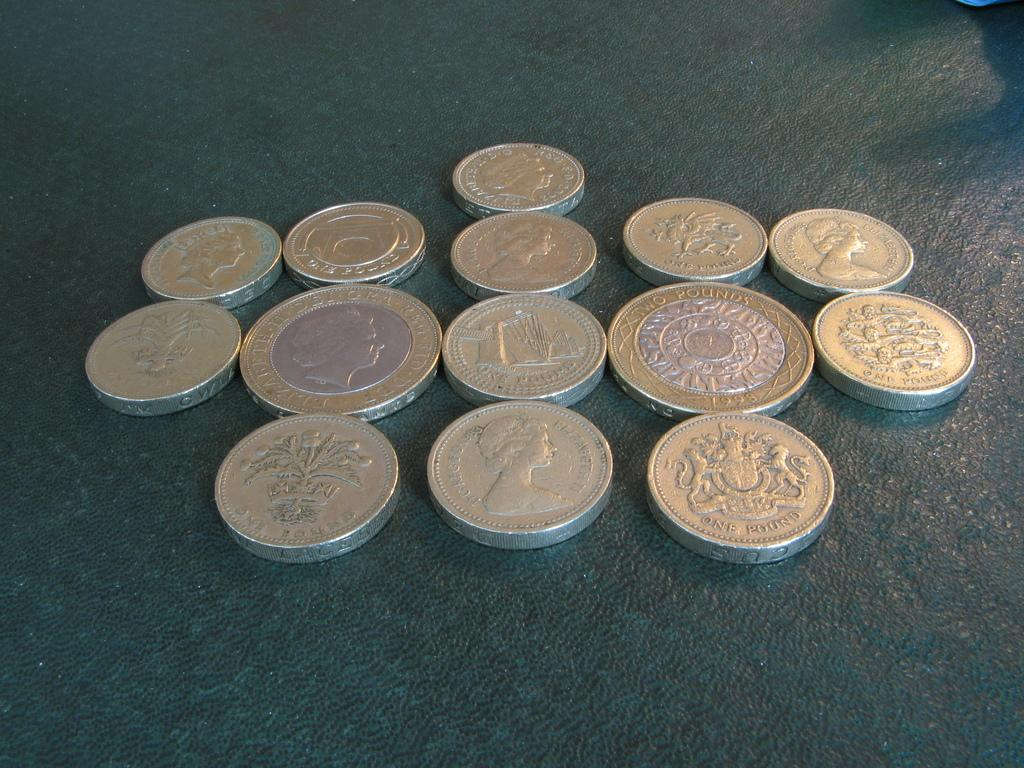<image>
Provide a brief description of the given image. Fourteen coins with some having the Queen on them are shown with one minted in 1998. 